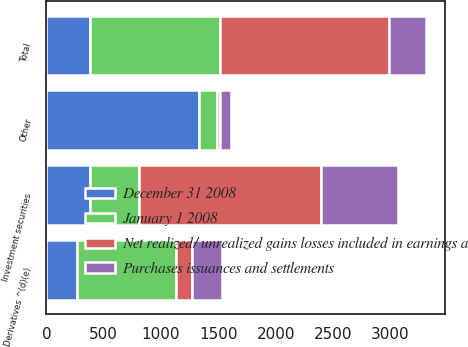Convert chart to OTSL. <chart><loc_0><loc_0><loc_500><loc_500><stacked_bar_chart><ecel><fcel>Investment securities<fcel>Derivatives ^(d)(e)<fcel>Other<fcel>Total<nl><fcel>December 31 2008<fcel>377.5<fcel>265<fcel>1330<fcel>377.5<nl><fcel>January 1 2008<fcel>430<fcel>866<fcel>157<fcel>1139<nl><fcel>Net realized/ unrealized gains losses included in earnings a<fcel>1586<fcel>141<fcel>29<fcel>1474<nl><fcel>Purchases issuances and settlements<fcel>671<fcel>256<fcel>90<fcel>325<nl></chart> 